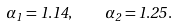Convert formula to latex. <formula><loc_0><loc_0><loc_500><loc_500>\alpha _ { 1 } = 1 . 1 4 , \quad \alpha _ { 2 } = 1 . 2 5 .</formula> 